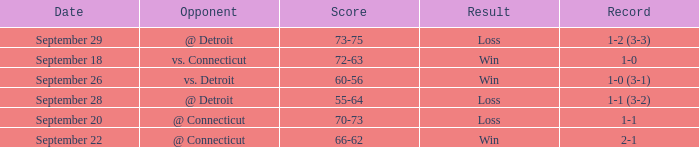WHAT IS THE SCORE WITH A RECORD OF 1-0? 72-63. 